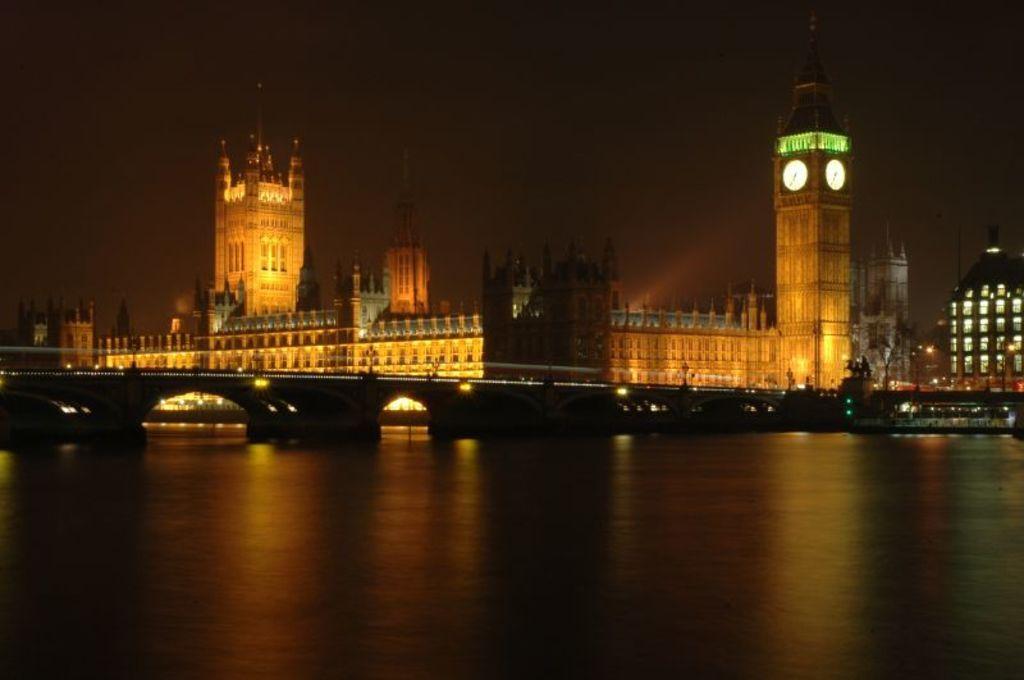Could you give a brief overview of what you see in this image? In this picture we can see a bridge, boat on the water and in the background we can see buildings, lights, statue, some objects and the sky. 